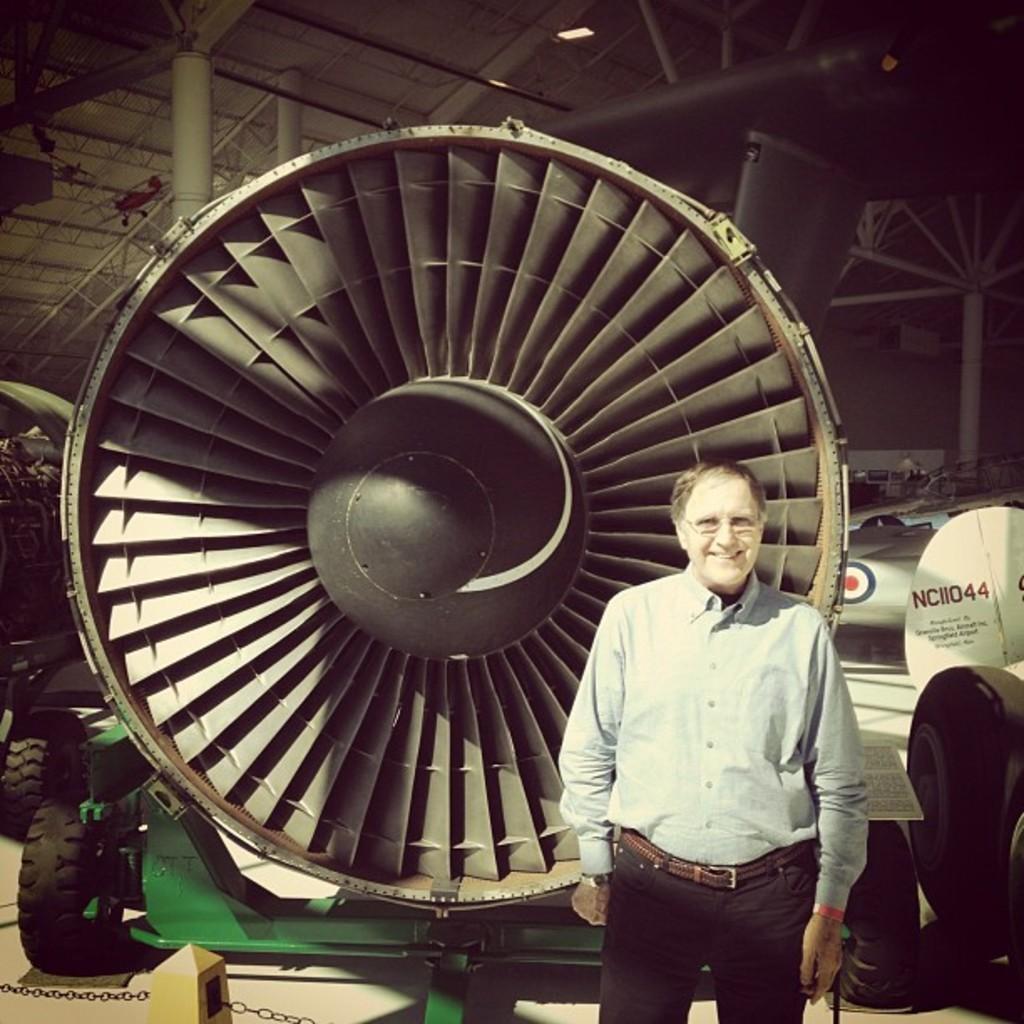Describe this image in one or two sentences. In this image we can see a man standing. On the backside we can see a jet fan placed on the stand containing some tires to it. We can also see a roof with some metal poles, pillars, frames and some ceiling lights. 